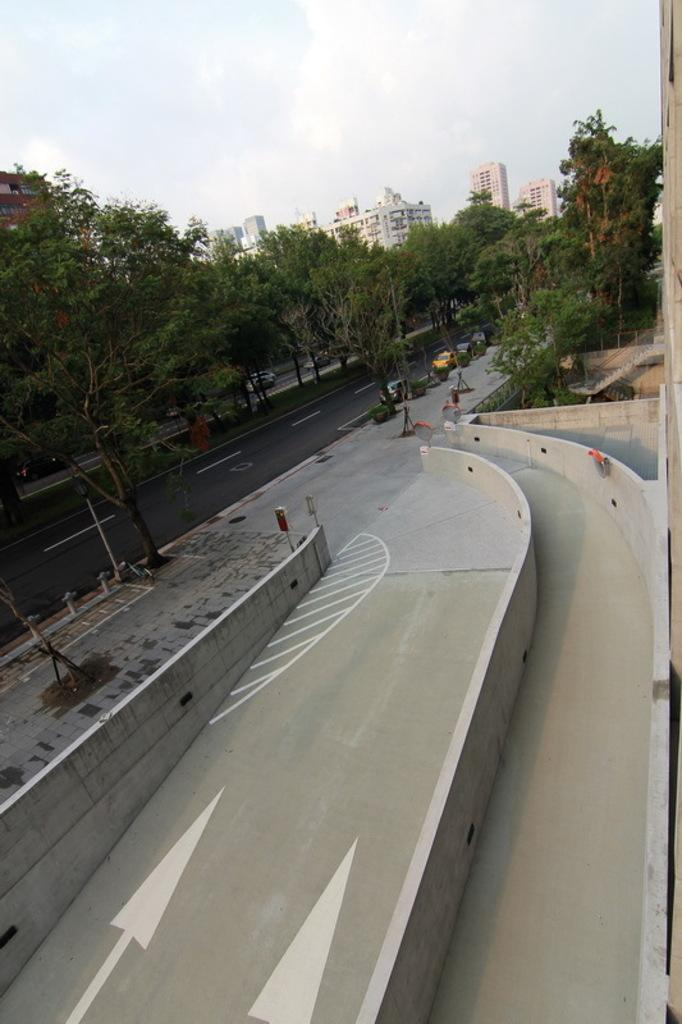What type of natural elements can be seen in the image? There are trees in the image. What man-made structure is present in the image? There is a fence in the image. What type of transportation is visible in the image? There are fleets of vehicles on the road in the image. What type of human-made structures can be seen in the image? There are buildings in the image. What part of the natural environment is visible in the image? The sky is visible in the image. From where might the image have been taken? The image appears to be taken from a roadside perspective. What type of coil is used to celebrate the birthday in the image? There is no coil or birthday celebration present in the image. What is the day of the week in the image? The day of the week is not mentioned or visible in the image. 